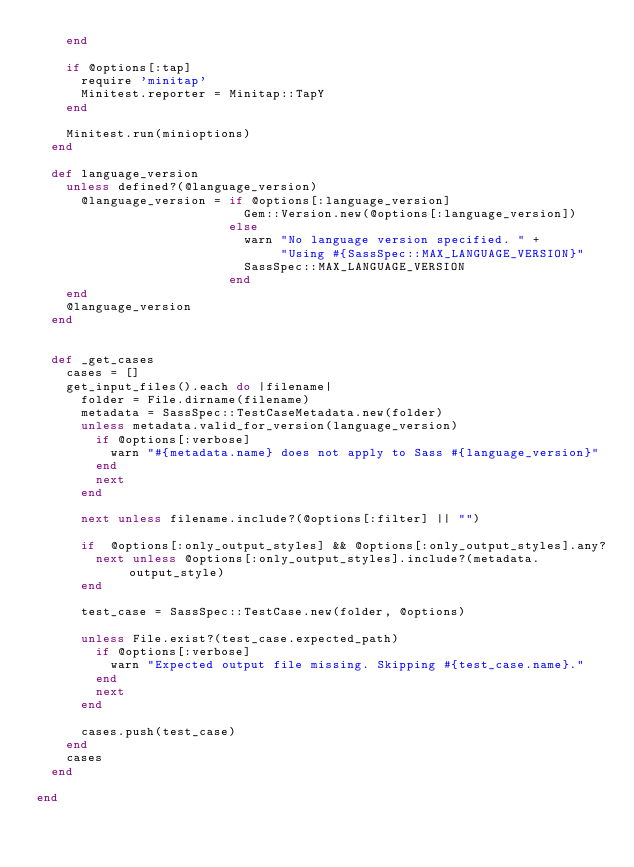Convert code to text. <code><loc_0><loc_0><loc_500><loc_500><_Ruby_>    end

    if @options[:tap]
      require 'minitap'
      Minitest.reporter = Minitap::TapY
    end

    Minitest.run(minioptions)
  end

  def language_version
    unless defined?(@language_version)
      @language_version = if @options[:language_version]
                            Gem::Version.new(@options[:language_version])
                          else
                            warn "No language version specified. " +
                                 "Using #{SassSpec::MAX_LANGUAGE_VERSION}"
                            SassSpec::MAX_LANGUAGE_VERSION
                          end
    end
    @language_version
  end


  def _get_cases
    cases = []
    get_input_files().each do |filename|
      folder = File.dirname(filename)
      metadata = SassSpec::TestCaseMetadata.new(folder)
      unless metadata.valid_for_version(language_version)
        if @options[:verbose]
          warn "#{metadata.name} does not apply to Sass #{language_version}"
        end
        next
      end

      next unless filename.include?(@options[:filter] || "")

      if  @options[:only_output_styles] && @options[:only_output_styles].any?
        next unless @options[:only_output_styles].include?(metadata.output_style)
      end

      test_case = SassSpec::TestCase.new(folder, @options)

      unless File.exist?(test_case.expected_path)
        if @options[:verbose]
          warn "Expected output file missing. Skipping #{test_case.name}."
        end
        next
      end

      cases.push(test_case)
    end
    cases
  end

end
</code> 